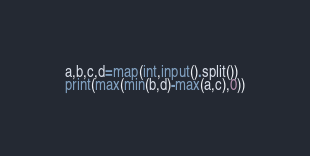<code> <loc_0><loc_0><loc_500><loc_500><_Python_>a,b,c,d=map(int,input().split())
print(max(min(b,d)-max(a,c),0))</code> 